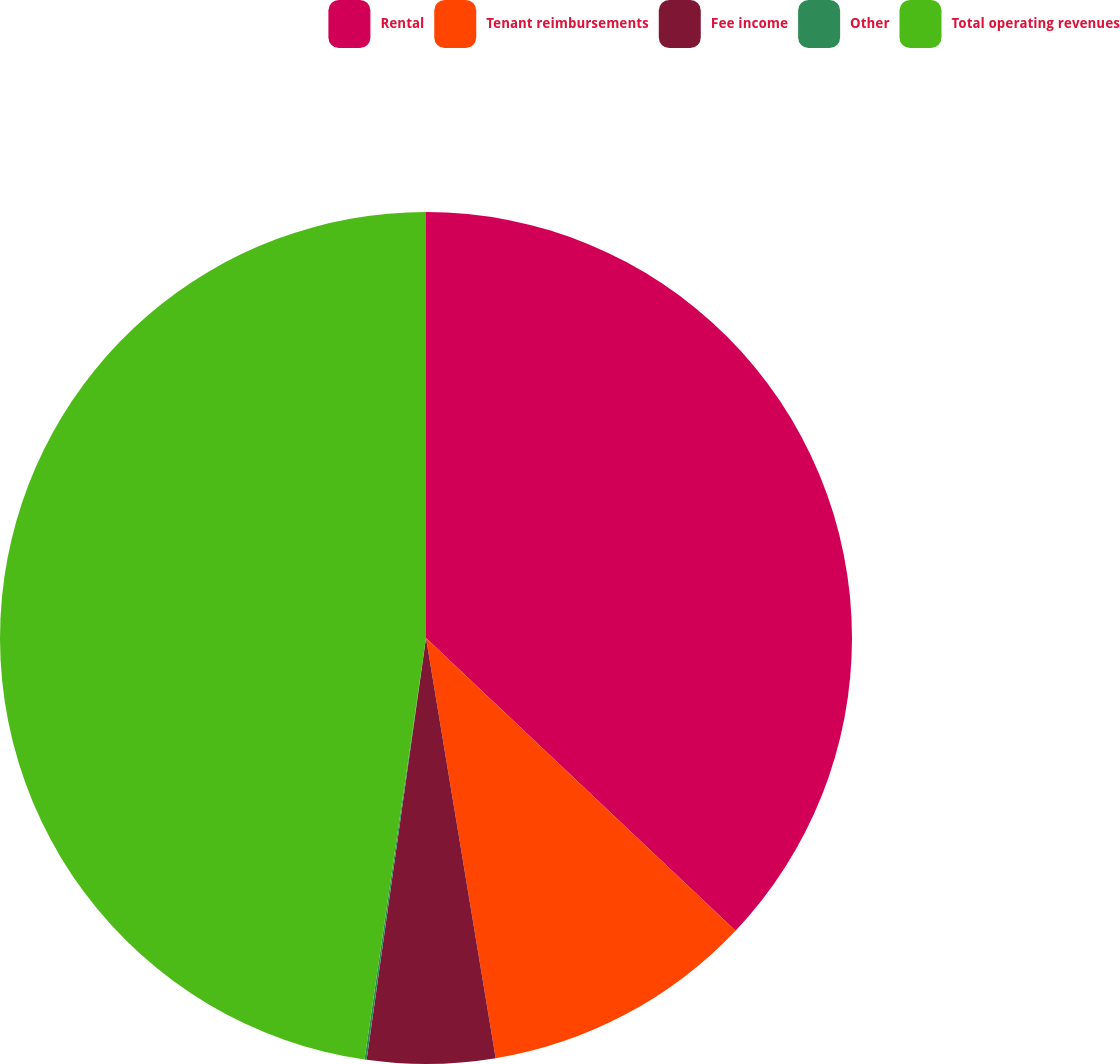<chart> <loc_0><loc_0><loc_500><loc_500><pie_chart><fcel>Rental<fcel>Tenant reimbursements<fcel>Fee income<fcel>Other<fcel>Total operating revenues<nl><fcel>37.05%<fcel>10.33%<fcel>4.84%<fcel>0.08%<fcel>47.69%<nl></chart> 